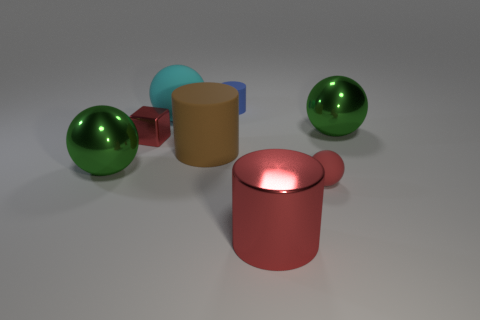Does the rubber sphere on the right side of the large red cylinder have the same color as the cube?
Keep it short and to the point. Yes. There is a cylinder that is both right of the large brown cylinder and behind the tiny red ball; what material is it?
Ensure brevity in your answer.  Rubber. Are there any big green metallic objects that are in front of the object that is behind the big cyan matte object?
Your answer should be compact. Yes. Does the brown thing have the same material as the blue thing?
Ensure brevity in your answer.  Yes. What shape is the tiny thing that is to the right of the tiny red cube and in front of the large cyan ball?
Provide a short and direct response. Sphere. There is a cylinder that is behind the green ball on the right side of the big cyan rubber ball; what size is it?
Offer a terse response. Small. What number of big red objects have the same shape as the big brown rubber object?
Your answer should be compact. 1. Does the tiny metal object have the same color as the tiny rubber sphere?
Ensure brevity in your answer.  Yes. Is there anything else that has the same shape as the small red metallic thing?
Your answer should be very brief. No. Is there another ball that has the same color as the tiny sphere?
Offer a very short reply. No. 